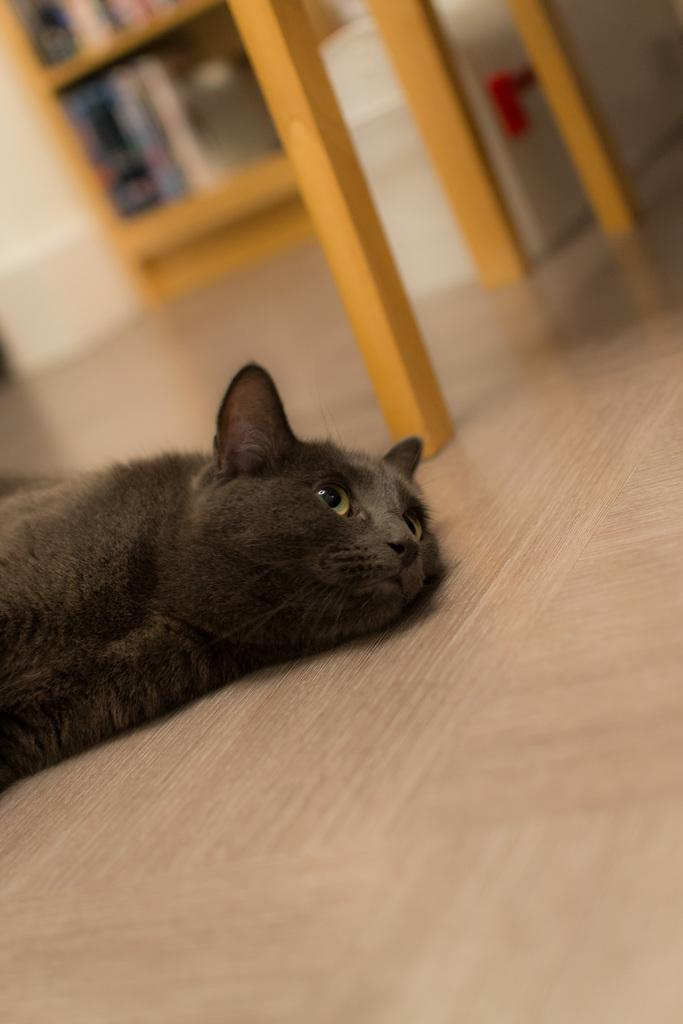What is on the floor in the image? There is an animal on the floor in the image. What can be found near the animal? There are wooden objects beside the animal. How many houses can be seen in the image? There are no houses present in the image. What type of oven is being used by the men in the image? There are no men or ovens present in the image. 